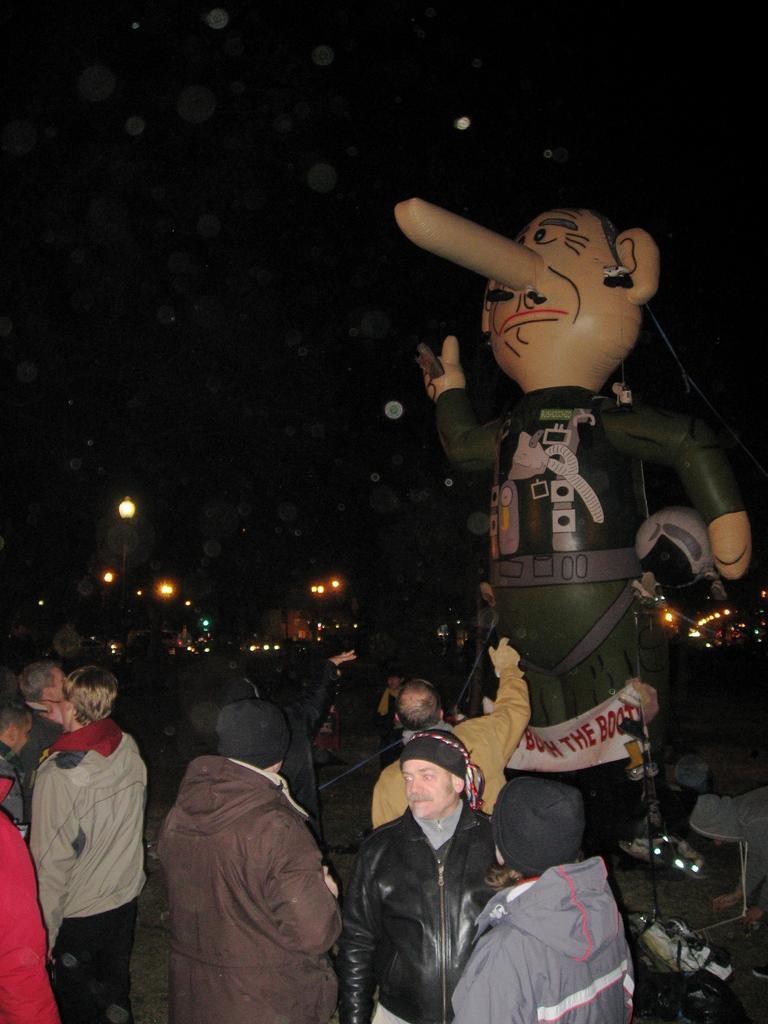Describe this image in one or two sentences. In the image there are many people standing on road with a toy statue on the right side and in the background there are lights. 